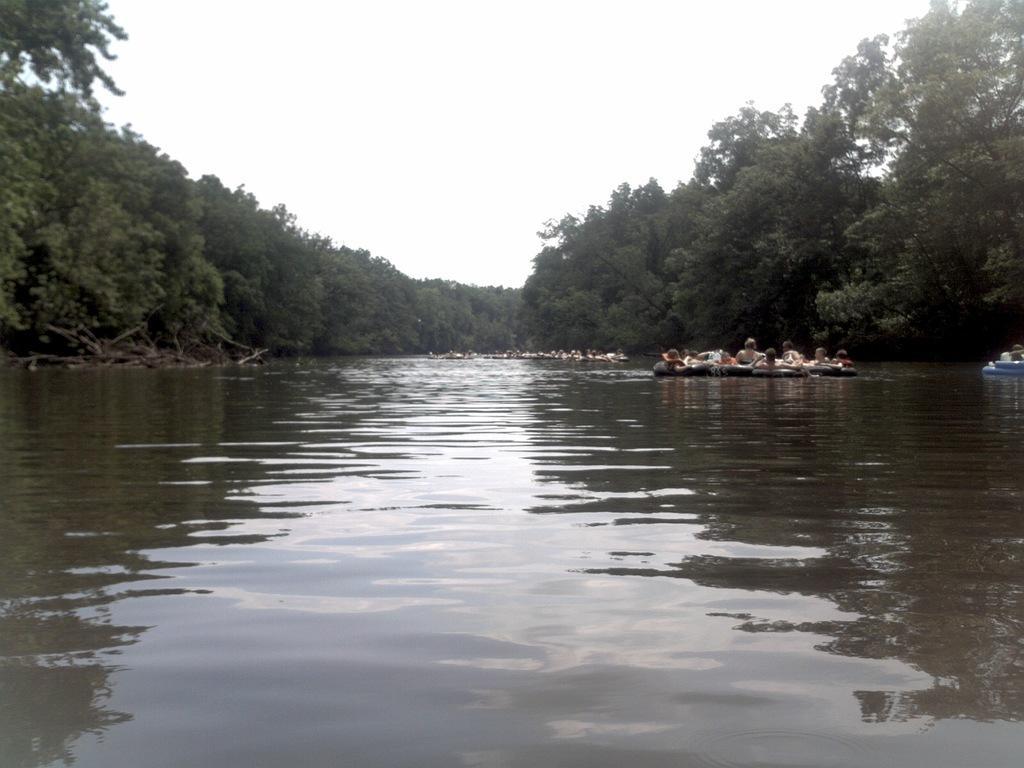Please provide a concise description of this image. In this picture there is a river water. Behind there are some persons in the boat. In the background we can see some trees. 